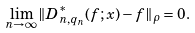<formula> <loc_0><loc_0><loc_500><loc_500>\lim _ { n \to \infty } \| D _ { n , q _ { n } } ^ { * } ( f ; x ) - f \| _ { \rho } = 0 .</formula> 